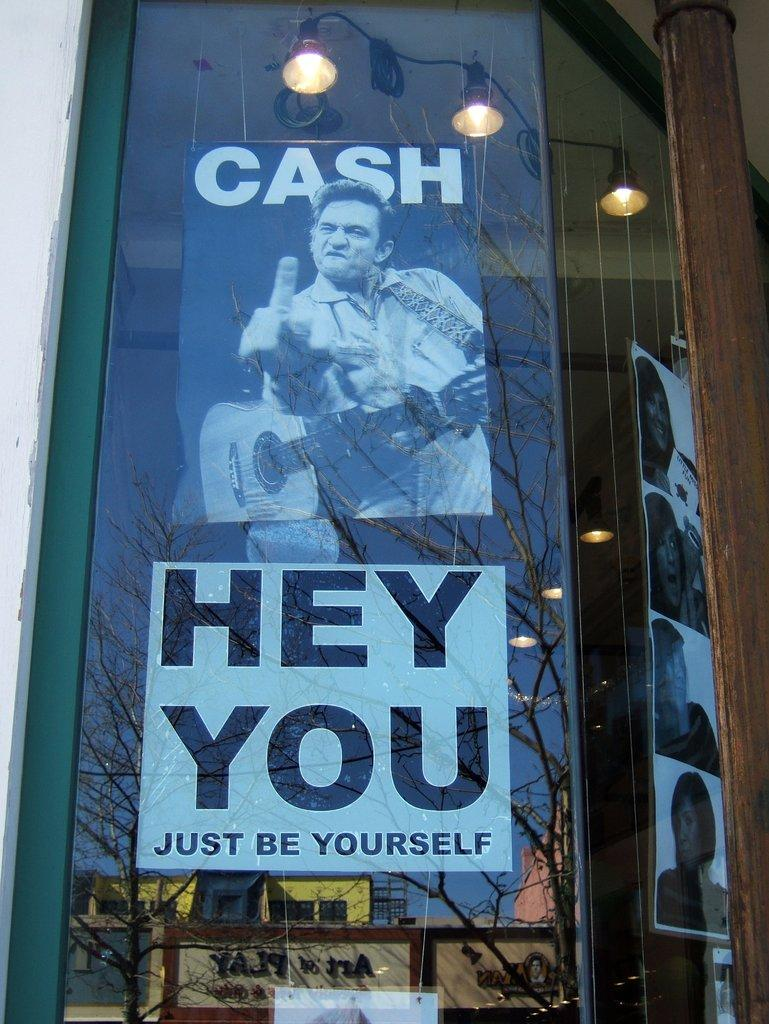What is the main subject of the image? There is an advertisement in the image. What can be seen in the reflection of the image? The reflection of trees, the sky, and buildings are visible in the image. What else is reflected in the image? A name board is reflected in the mirror in the image. How much money is being exchanged in the image? There is no exchange of money depicted in the image. What type of prose is being written on the advertisement? The image does not show any writing or prose on the advertisement. 